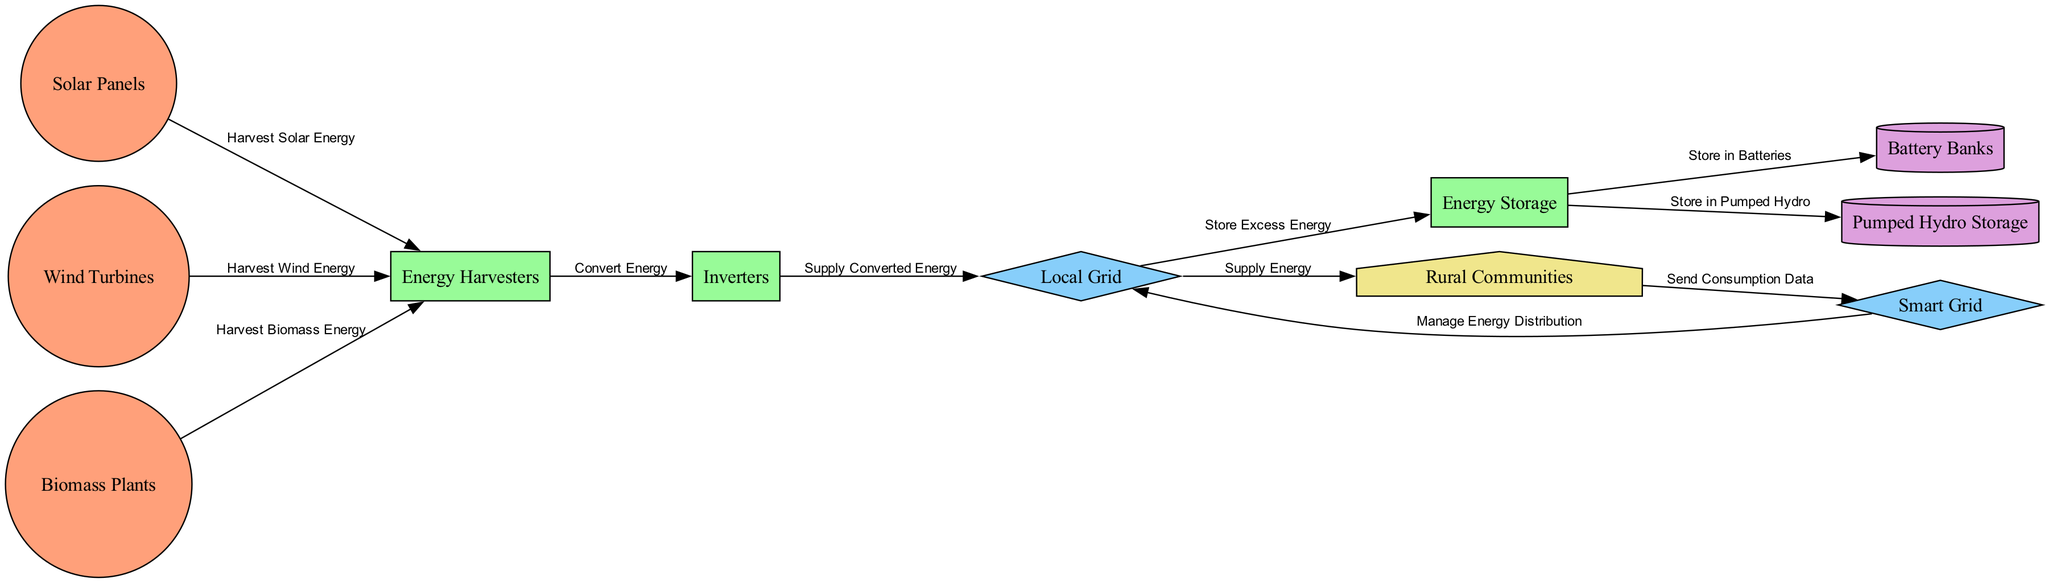What energy sources are integrated into the diagram? The nodes labeled as "Solar Panels," "Wind Turbines," and "Biomass Plants" represent the energy sources integrated into the diagram. These nodes directly show the types of renewable energy utilized in the integration process.
Answer: Solar Panels, Wind Turbines, Biomass Plants How many storage types are indicated in the diagram? The diagram includes two types of energy storage: "Battery Banks" and "Pumped Hydro Storage." By counting the storage nodes, you can determine the total number.
Answer: 2 What component converts harvested energy into usable energy in the diagram? The "Inverters" node is responsible for converting the energy harvested from different sources into a usable form. This is indicated by the directional arrow leading from "Energy Harvesters" to "Inverters."
Answer: Inverters Which node receives energy from the local grid? The "Rural Communities" node represents the end-users that receive energy from the "Local Grid." The edge connecting these two nodes clearly indicates the flow of energy supply.
Answer: Rural Communities What process is represented by the edge labeled "Store Excess Energy"? This edge connects the "Local Grid" to the "Energy Storage" node, signifying that any excess energy generated is directed to storage solutions for later use. The edge label clarifies this function within the integration schema.
Answer: Store Excess Energy How do rural communities interact with the smart grid? The diagram shows a connection where the "Rural Communities" send consumption data to the "Smart Grid." This interaction is crucial for efficient energy distribution management.
Answer: Send Consumption Data Which component is involved in managing energy distribution? The "Smart Grid" node is responsible for managing energy distribution, as indicated by the edge connecting it to the "Local Grid." This highlights its role as a central management system for energy flow.
Answer: Smart Grid What type of grid is indicated in the diagram? Two types of grids are presented: "Local Grid" and "Smart Grid." The diagram shows a distinction between these grids and their respective functions related to energy supply and distribution.
Answer: Local Grid, Smart Grid Which energy source directly utilizes biomass? Through the node labeled "Biomass Plants," the diagram indicates the integration of biomass energy as one of the renewable sources harnessed for energy production. This labels the specific type tied to biomass.
Answer: Biomass Plants 